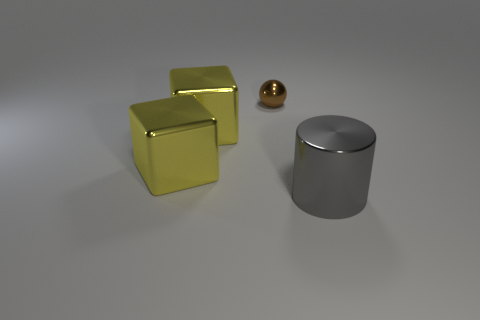Subtract 1 spheres. How many spheres are left? 0 Add 4 large shiny cylinders. How many objects exist? 8 Subtract 0 brown blocks. How many objects are left? 4 Subtract all cylinders. How many objects are left? 3 Subtract all purple blocks. Subtract all gray cylinders. How many blocks are left? 2 Subtract all purple balls. How many green cubes are left? 0 Subtract all balls. Subtract all spheres. How many objects are left? 2 Add 1 gray metal objects. How many gray metal objects are left? 2 Add 1 large yellow things. How many large yellow things exist? 3 